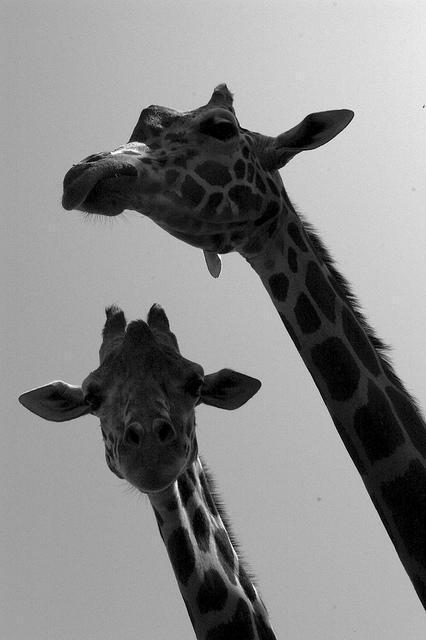How many giraffes are visible?
Give a very brief answer. 2. 